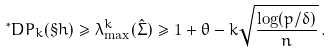<formula> <loc_0><loc_0><loc_500><loc_500>^ { * } D P _ { k } ( \S h ) \geq \lambda ^ { k } _ { \max } ( \hat { \Sigma } ) \geq 1 + \theta - k \sqrt { \frac { \log ( p / \delta ) } { n } } \, .</formula> 